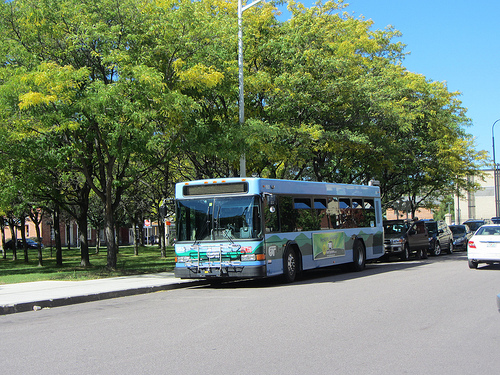Which side of the picture is the car on? The car is on the right side of the picture. 